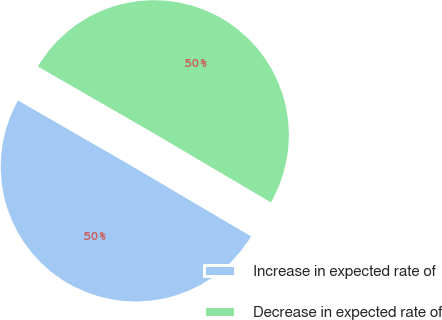Convert chart. <chart><loc_0><loc_0><loc_500><loc_500><pie_chart><fcel>Increase in expected rate of<fcel>Decrease in expected rate of<nl><fcel>49.84%<fcel>50.16%<nl></chart> 